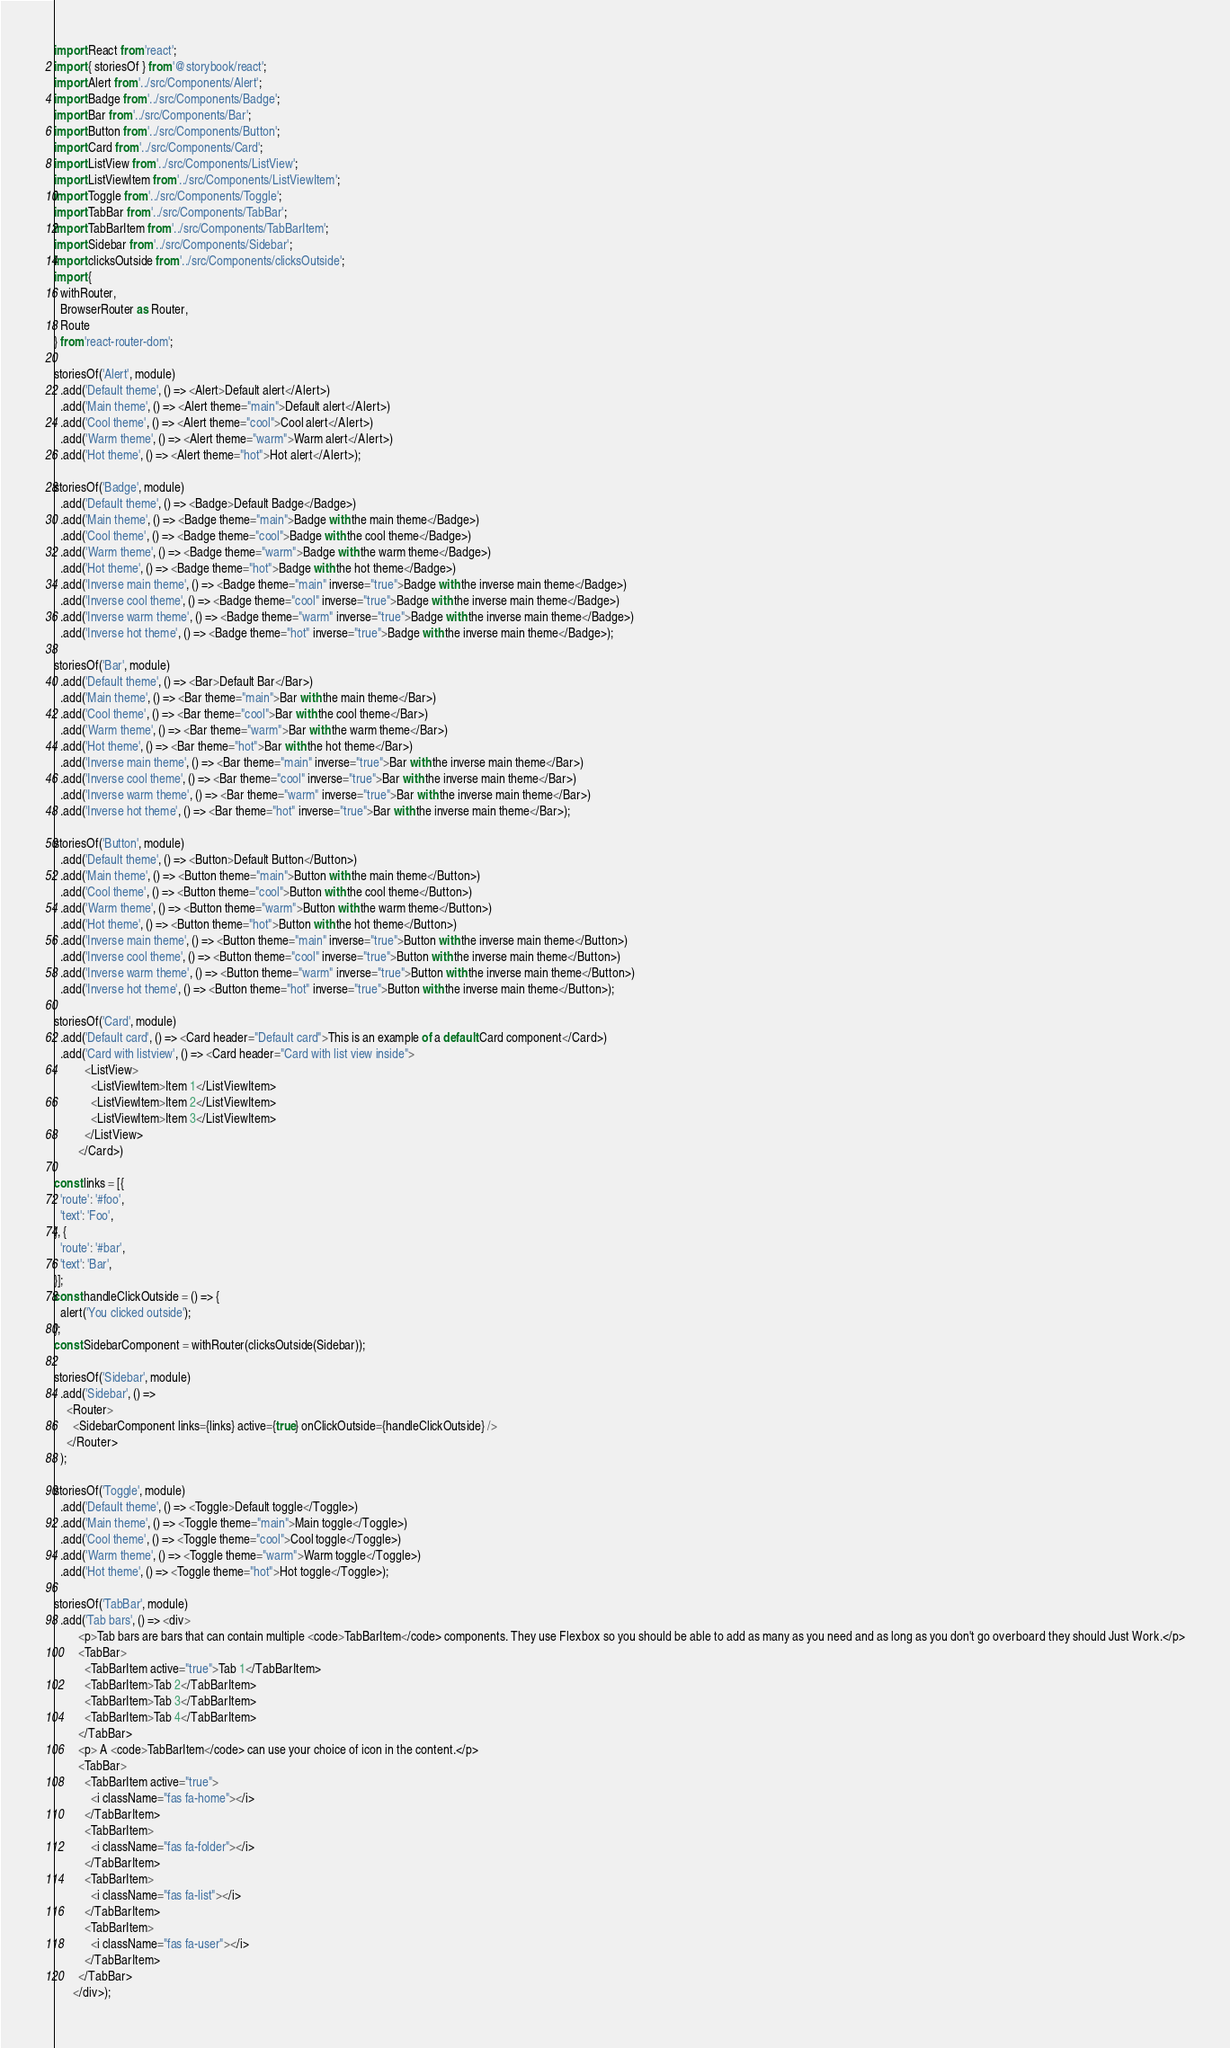<code> <loc_0><loc_0><loc_500><loc_500><_JavaScript_>import React from 'react';
import { storiesOf } from '@storybook/react';
import Alert from '../src/Components/Alert';
import Badge from '../src/Components/Badge';
import Bar from '../src/Components/Bar';
import Button from '../src/Components/Button';
import Card from '../src/Components/Card';
import ListView from '../src/Components/ListView';
import ListViewItem from '../src/Components/ListViewItem';
import Toggle from '../src/Components/Toggle';
import TabBar from '../src/Components/TabBar';
import TabBarItem from '../src/Components/TabBarItem';
import Sidebar from '../src/Components/Sidebar';
import clicksOutside from '../src/Components/clicksOutside';
import {
  withRouter,
  BrowserRouter as Router,
  Route
} from 'react-router-dom';

storiesOf('Alert', module)
  .add('Default theme', () => <Alert>Default alert</Alert>)
  .add('Main theme', () => <Alert theme="main">Default alert</Alert>)
  .add('Cool theme', () => <Alert theme="cool">Cool alert</Alert>)
  .add('Warm theme', () => <Alert theme="warm">Warm alert</Alert>)
  .add('Hot theme', () => <Alert theme="hot">Hot alert</Alert>);

storiesOf('Badge', module)
  .add('Default theme', () => <Badge>Default Badge</Badge>)
  .add('Main theme', () => <Badge theme="main">Badge with the main theme</Badge>)
  .add('Cool theme', () => <Badge theme="cool">Badge with the cool theme</Badge>)
  .add('Warm theme', () => <Badge theme="warm">Badge with the warm theme</Badge>)
  .add('Hot theme', () => <Badge theme="hot">Badge with the hot theme</Badge>)
  .add('Inverse main theme', () => <Badge theme="main" inverse="true">Badge with the inverse main theme</Badge>)
  .add('Inverse cool theme', () => <Badge theme="cool" inverse="true">Badge with the inverse main theme</Badge>)
  .add('Inverse warm theme', () => <Badge theme="warm" inverse="true">Badge with the inverse main theme</Badge>)
  .add('Inverse hot theme', () => <Badge theme="hot" inverse="true">Badge with the inverse main theme</Badge>);

storiesOf('Bar', module)
  .add('Default theme', () => <Bar>Default Bar</Bar>)
  .add('Main theme', () => <Bar theme="main">Bar with the main theme</Bar>)
  .add('Cool theme', () => <Bar theme="cool">Bar with the cool theme</Bar>)
  .add('Warm theme', () => <Bar theme="warm">Bar with the warm theme</Bar>)
  .add('Hot theme', () => <Bar theme="hot">Bar with the hot theme</Bar>)
  .add('Inverse main theme', () => <Bar theme="main" inverse="true">Bar with the inverse main theme</Bar>)
  .add('Inverse cool theme', () => <Bar theme="cool" inverse="true">Bar with the inverse main theme</Bar>)
  .add('Inverse warm theme', () => <Bar theme="warm" inverse="true">Bar with the inverse main theme</Bar>)
  .add('Inverse hot theme', () => <Bar theme="hot" inverse="true">Bar with the inverse main theme</Bar>);

storiesOf('Button', module)
  .add('Default theme', () => <Button>Default Button</Button>)
  .add('Main theme', () => <Button theme="main">Button with the main theme</Button>)
  .add('Cool theme', () => <Button theme="cool">Button with the cool theme</Button>)
  .add('Warm theme', () => <Button theme="warm">Button with the warm theme</Button>)
  .add('Hot theme', () => <Button theme="hot">Button with the hot theme</Button>)
  .add('Inverse main theme', () => <Button theme="main" inverse="true">Button with the inverse main theme</Button>)
  .add('Inverse cool theme', () => <Button theme="cool" inverse="true">Button with the inverse main theme</Button>)
  .add('Inverse warm theme', () => <Button theme="warm" inverse="true">Button with the inverse main theme</Button>)
  .add('Inverse hot theme', () => <Button theme="hot" inverse="true">Button with the inverse main theme</Button>);

storiesOf('Card', module)
  .add('Default card', () => <Card header="Default card">This is an example of a default Card component</Card>)
  .add('Card with listview', () => <Card header="Card with list view inside">
          <ListView>
            <ListViewItem>Item 1</ListViewItem>
            <ListViewItem>Item 2</ListViewItem>
            <ListViewItem>Item 3</ListViewItem>
          </ListView>
        </Card>)

const links = [{
  'route': '#foo',
  'text': 'Foo',
}, {
  'route': '#bar',
  'text': 'Bar',
}];
const handleClickOutside = () => {
  alert('You clicked outside');
};
const SidebarComponent = withRouter(clicksOutside(Sidebar));

storiesOf('Sidebar', module)
  .add('Sidebar', () => 
    <Router>
      <SidebarComponent links={links} active={true} onClickOutside={handleClickOutside} />
    </Router>
  );

storiesOf('Toggle', module)
  .add('Default theme', () => <Toggle>Default toggle</Toggle>)
  .add('Main theme', () => <Toggle theme="main">Main toggle</Toggle>)
  .add('Cool theme', () => <Toggle theme="cool">Cool toggle</Toggle>)
  .add('Warm theme', () => <Toggle theme="warm">Warm toggle</Toggle>)
  .add('Hot theme', () => <Toggle theme="hot">Hot toggle</Toggle>);

storiesOf('TabBar', module)
  .add('Tab bars', () => <div>
        <p>Tab bars are bars that can contain multiple <code>TabBarItem</code> components. They use Flexbox so you should be able to add as many as you need and as long as you don't go overboard they should Just Work.</p>
        <TabBar>
          <TabBarItem active="true">Tab 1</TabBarItem>
          <TabBarItem>Tab 2</TabBarItem>
          <TabBarItem>Tab 3</TabBarItem>
          <TabBarItem>Tab 4</TabBarItem>
        </TabBar>
        <p> A <code>TabBarItem</code> can use your choice of icon in the content.</p>
        <TabBar>
          <TabBarItem active="true">
            <i className="fas fa-home"></i>
          </TabBarItem>
          <TabBarItem>
            <i className="fas fa-folder"></i>
          </TabBarItem>
          <TabBarItem>
            <i className="fas fa-list"></i>
          </TabBarItem>
          <TabBarItem>
            <i className="fas fa-user"></i>
          </TabBarItem>
        </TabBar>
      </div>);

</code> 